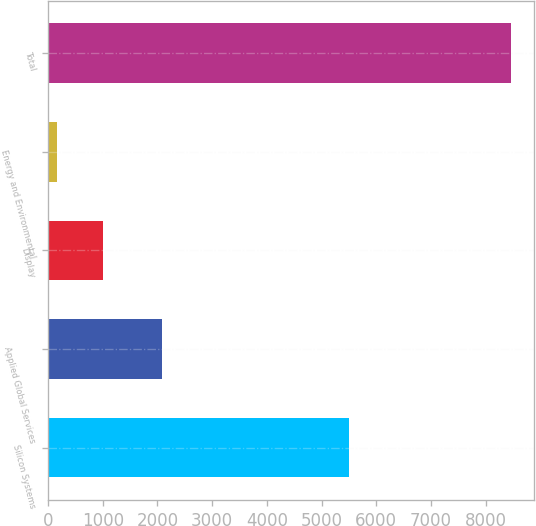<chart> <loc_0><loc_0><loc_500><loc_500><bar_chart><fcel>Silicon Systems<fcel>Applied Global Services<fcel>Display<fcel>Energy and Environmental<fcel>Total<nl><fcel>5507<fcel>2090<fcel>996<fcel>166<fcel>8466<nl></chart> 